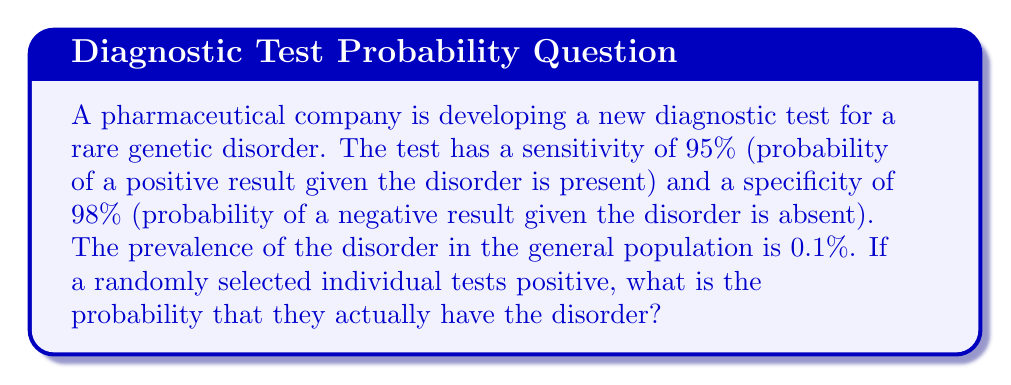Solve this math problem. Let's approach this problem using Bayes' theorem:

1. Define the events:
   $D$: The individual has the disorder
   $T+$: The test result is positive

2. Given information:
   $P(D) = 0.001$ (prevalence of 0.1%)
   $P(T+|D) = 0.95$ (sensitivity)
   $P(T-|\neg D) = 0.98$ (specificity)

3. Calculate $P(T+|\neg D)$:
   $P(T+|\neg D) = 1 - P(T-|\neg D) = 1 - 0.98 = 0.02$

4. Apply Bayes' theorem:

   $$P(D|T+) = \frac{P(T+|D) \cdot P(D)}{P(T+|D) \cdot P(D) + P(T+|\neg D) \cdot P(\neg D)}$$

5. Substitute the values:

   $$P(D|T+) = \frac{0.95 \cdot 0.001}{0.95 \cdot 0.001 + 0.02 \cdot 0.999}$$

6. Calculate:

   $$P(D|T+) = \frac{0.00095}{0.00095 + 0.01998} = \frac{0.00095}{0.02093} \approx 0.0454$$

7. Convert to percentage:

   $0.0454 \cdot 100\% \approx 4.54\%$
Answer: $4.54\%$ 